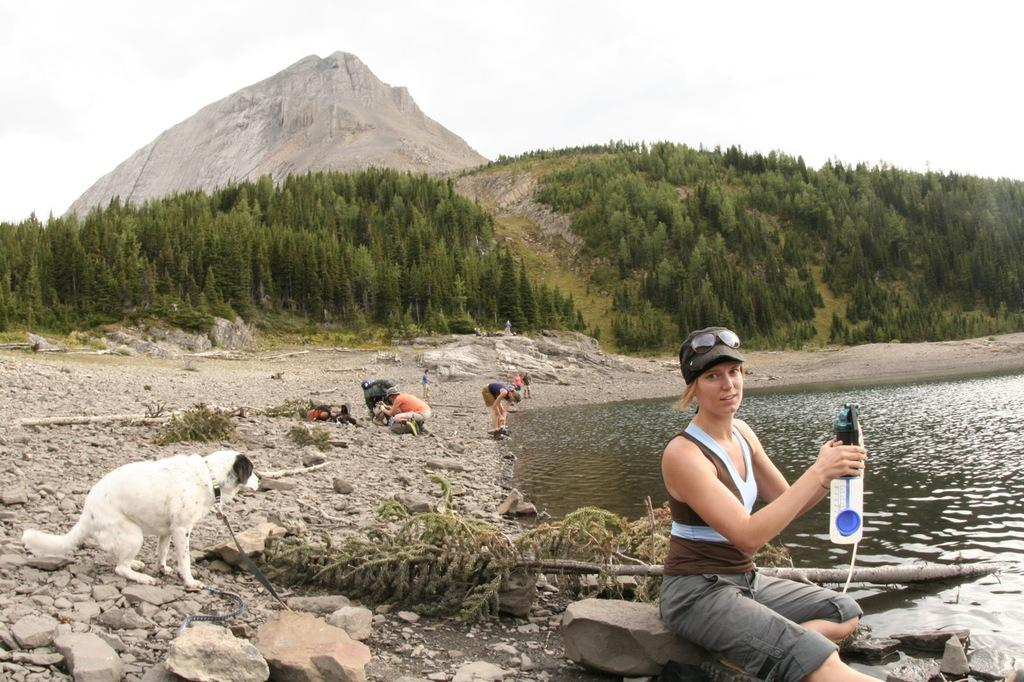What is the setting of the image? The setting of the image is near a lake. What are the people in the image doing? The people in the image are sitting near the lake. What animal is present in the image? There is a dog sitting on the ground in the image. What is the woman in the image holding? The woman is holding a water bottle in her hand. How many toes can be seen on the dog in the image? There are no visible toes on the dog in the image, as it is sitting on the ground. What type of sponge is being used by the people in the image? There is no sponge present in the image; the people are simply sitting near the lake. 